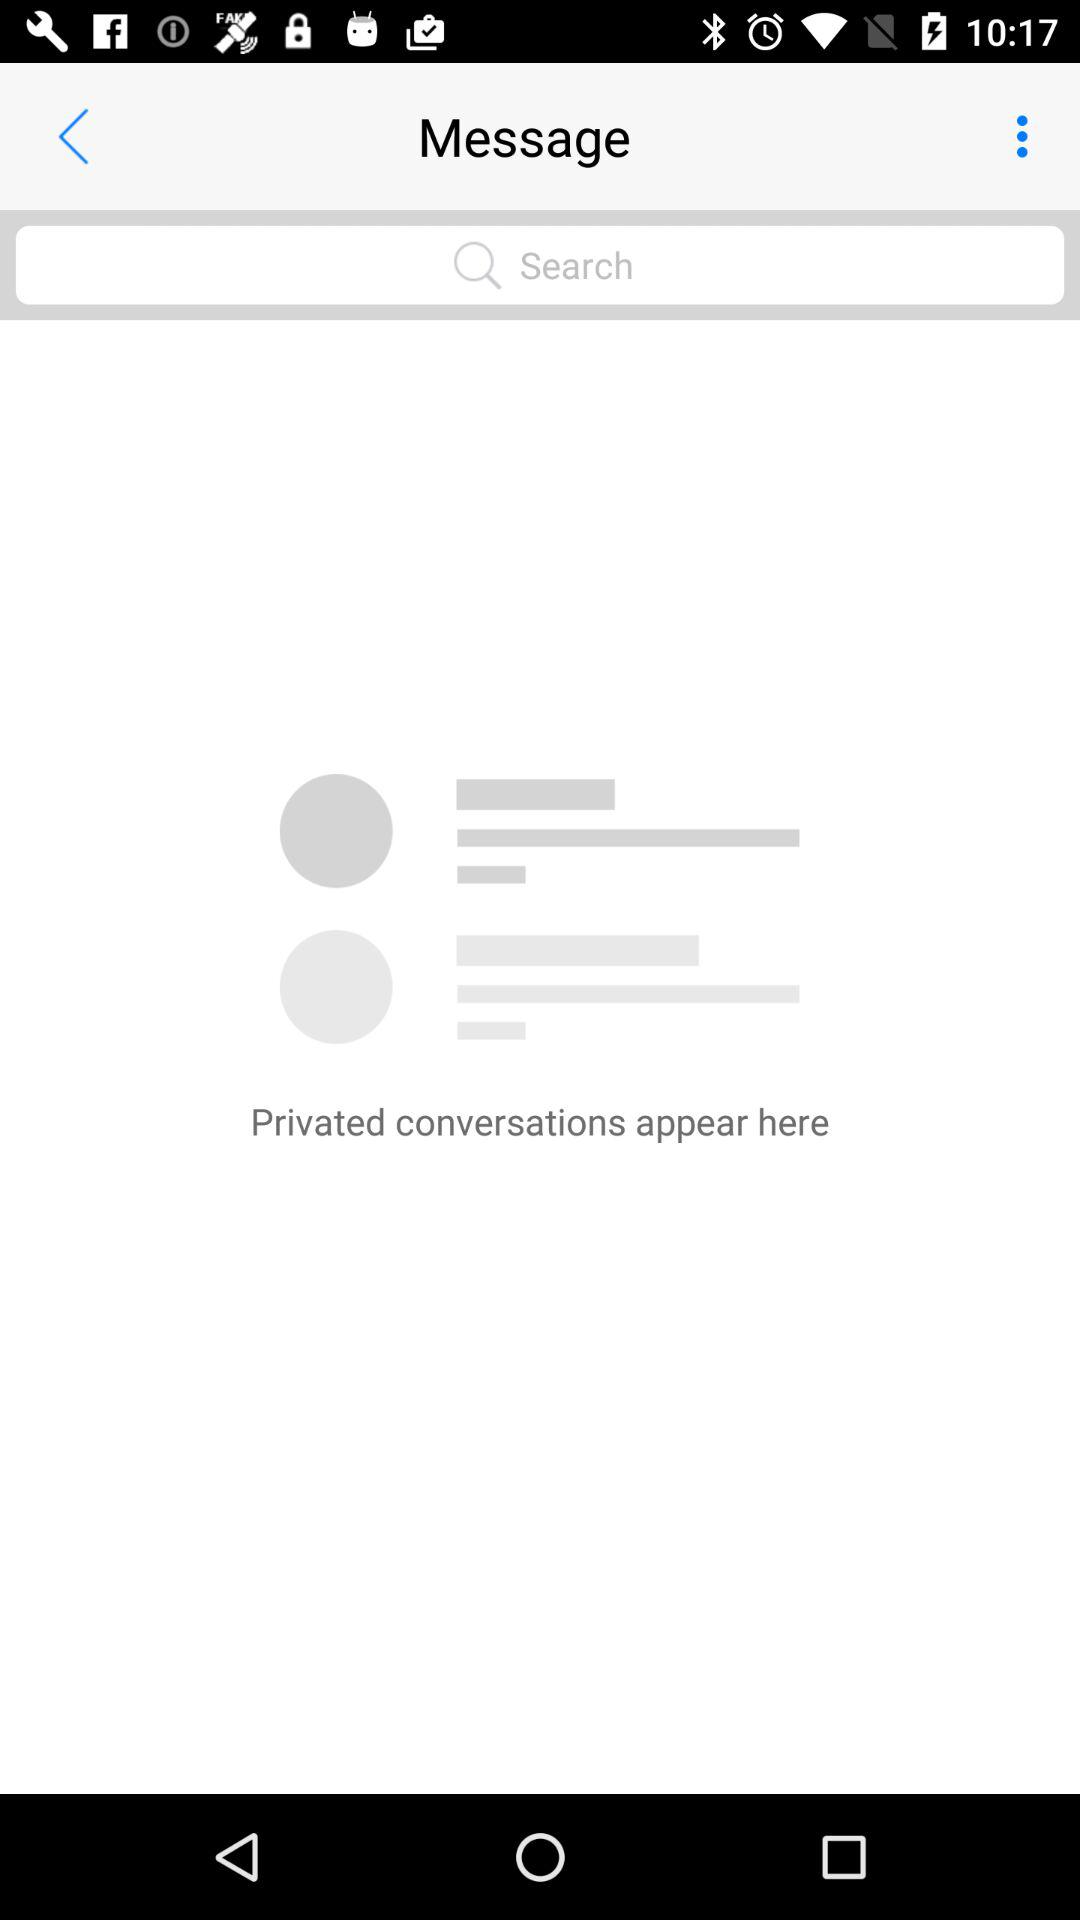What is the application name?
When the provided information is insufficient, respond with <no answer>. <no answer> 